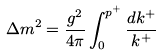Convert formula to latex. <formula><loc_0><loc_0><loc_500><loc_500>\Delta m ^ { 2 } = \frac { g ^ { 2 } } { 4 \pi } \int _ { 0 } ^ { p ^ { + } } \frac { d k ^ { + } } { k ^ { + } }</formula> 